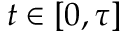<formula> <loc_0><loc_0><loc_500><loc_500>t \in [ 0 , \tau ]</formula> 